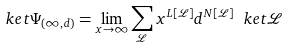<formula> <loc_0><loc_0><loc_500><loc_500>\ k e t { \Psi _ { ( \infty , d ) } } = { \lim _ { x \to \infty } } \sum _ { \mathcal { L } } x ^ { L [ \mathcal { L } ] } d ^ { N [ \mathcal { L } ] } \ k e t { \mathcal { L } }</formula> 